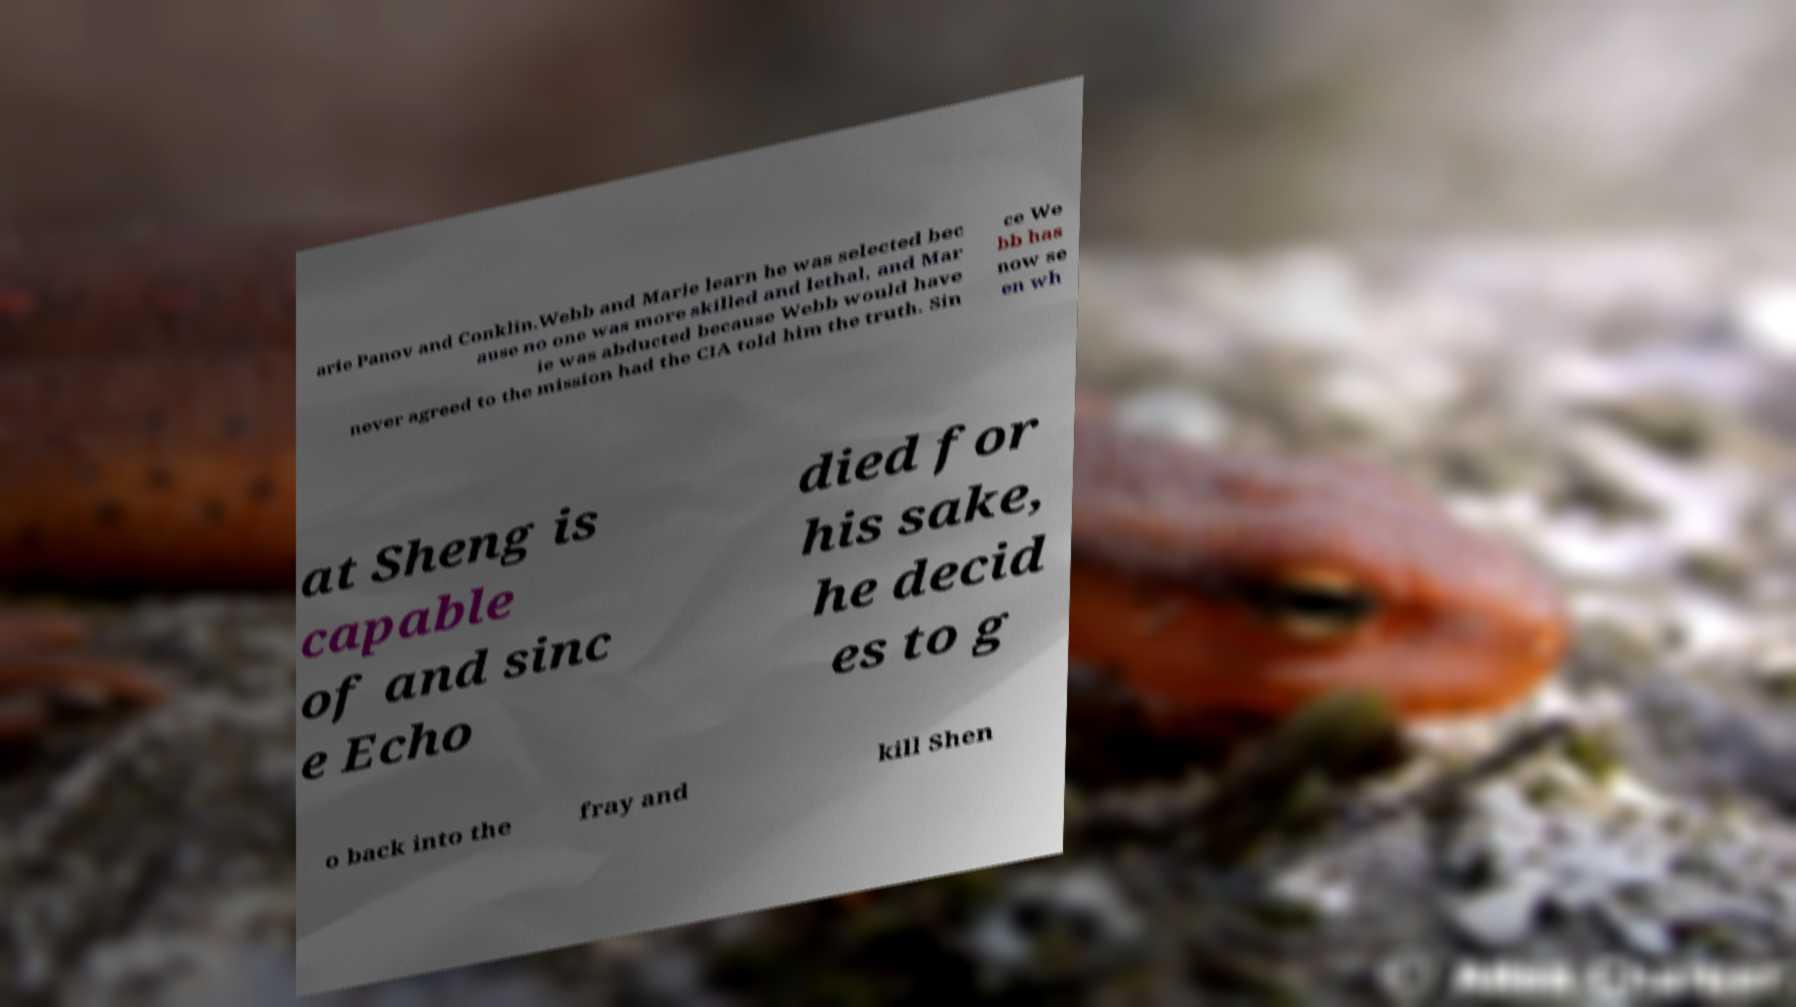For documentation purposes, I need the text within this image transcribed. Could you provide that? arie Panov and Conklin.Webb and Marie learn he was selected bec ause no one was more skilled and lethal, and Mar ie was abducted because Webb would have never agreed to the mission had the CIA told him the truth. Sin ce We bb has now se en wh at Sheng is capable of and sinc e Echo died for his sake, he decid es to g o back into the fray and kill Shen 